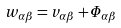Convert formula to latex. <formula><loc_0><loc_0><loc_500><loc_500>w _ { \alpha \beta } = v _ { \alpha \beta } + \varPhi _ { \alpha \beta }</formula> 